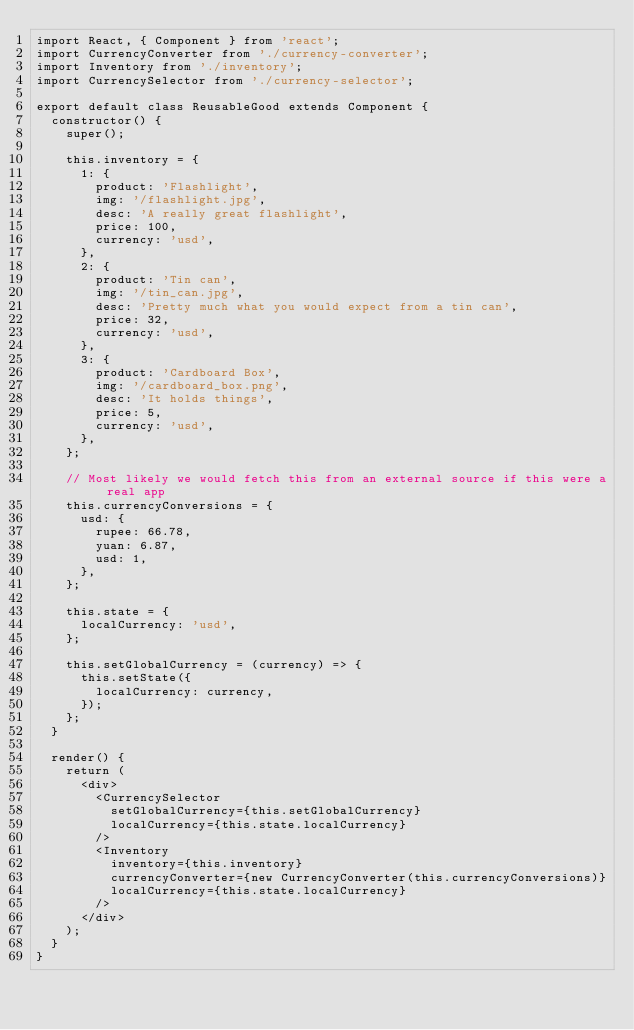<code> <loc_0><loc_0><loc_500><loc_500><_JavaScript_>import React, { Component } from 'react';
import CurrencyConverter from './currency-converter';
import Inventory from './inventory';
import CurrencySelector from './currency-selector';

export default class ReusableGood extends Component {
  constructor() {
    super();

    this.inventory = {
      1: {
        product: 'Flashlight',
        img: '/flashlight.jpg',
        desc: 'A really great flashlight',
        price: 100,
        currency: 'usd',
      },
      2: {
        product: 'Tin can',
        img: '/tin_can.jpg',
        desc: 'Pretty much what you would expect from a tin can',
        price: 32,
        currency: 'usd',
      },
      3: {
        product: 'Cardboard Box',
        img: '/cardboard_box.png',
        desc: 'It holds things',
        price: 5,
        currency: 'usd',
      },
    };

    // Most likely we would fetch this from an external source if this were a real app
    this.currencyConversions = {
      usd: {
        rupee: 66.78,
        yuan: 6.87,
        usd: 1,
      },
    };

    this.state = {
      localCurrency: 'usd',
    };

    this.setGlobalCurrency = (currency) => {
      this.setState({
        localCurrency: currency,
      });
    };
  }

  render() {
    return (
      <div>
        <CurrencySelector
          setGlobalCurrency={this.setGlobalCurrency}
          localCurrency={this.state.localCurrency}
        />
        <Inventory
          inventory={this.inventory}
          currencyConverter={new CurrencyConverter(this.currencyConversions)}
          localCurrency={this.state.localCurrency}
        />
      </div>
    );
  }
}
</code> 